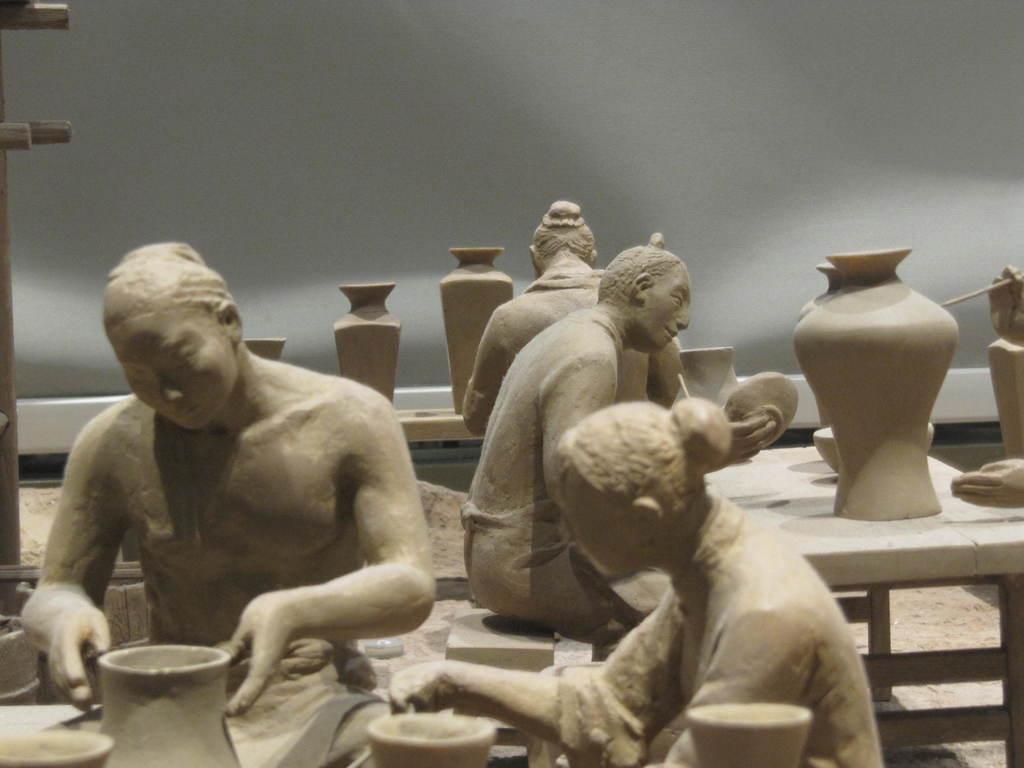Can you describe this image briefly? The picture consists of statues in a closed and at the left corner of the picture the statues are in a sitting position in front of the table and there are big pots and plates on the tables, behind the statues there is a white wall. 